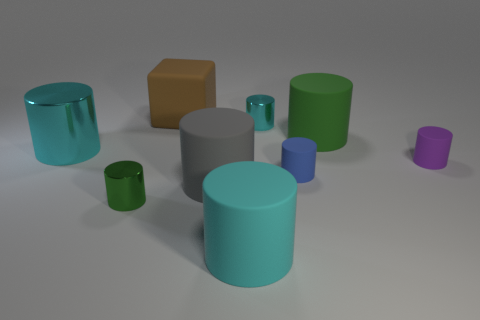Subtract all cyan cylinders. How many were subtracted if there are1cyan cylinders left? 2 Add 1 green matte blocks. How many objects exist? 10 Subtract all tiny green metallic cylinders. How many cylinders are left? 7 Subtract all gray cubes. How many cyan cylinders are left? 3 Subtract all blocks. How many objects are left? 8 Subtract all green cylinders. Subtract all red cubes. How many cylinders are left? 6 Subtract all rubber cylinders. Subtract all large gray cylinders. How many objects are left? 3 Add 8 small green metallic objects. How many small green metallic objects are left? 9 Add 7 cyan cylinders. How many cyan cylinders exist? 10 Subtract all purple cylinders. How many cylinders are left? 7 